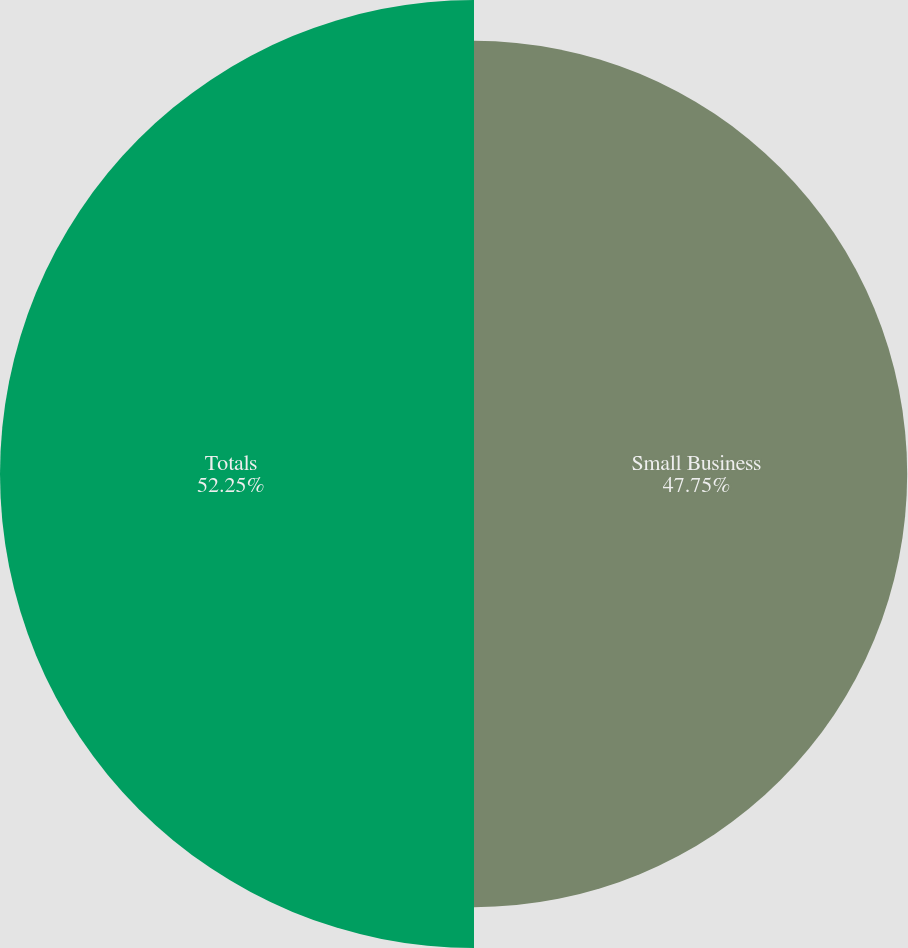Convert chart to OTSL. <chart><loc_0><loc_0><loc_500><loc_500><pie_chart><fcel>Small Business<fcel>Totals<nl><fcel>47.75%<fcel>52.25%<nl></chart> 